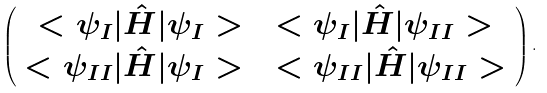Convert formula to latex. <formula><loc_0><loc_0><loc_500><loc_500>\left ( \begin{array} { c } < \psi _ { I } | \hat { H } | \psi _ { I } > \quad < \psi _ { I } | \hat { H } | \psi _ { I I } > \\ < \psi _ { I I } | \hat { H } | \psi _ { I } > \quad < \psi _ { I I } | \hat { H } | \psi _ { I I } > \end{array} \right ) .</formula> 